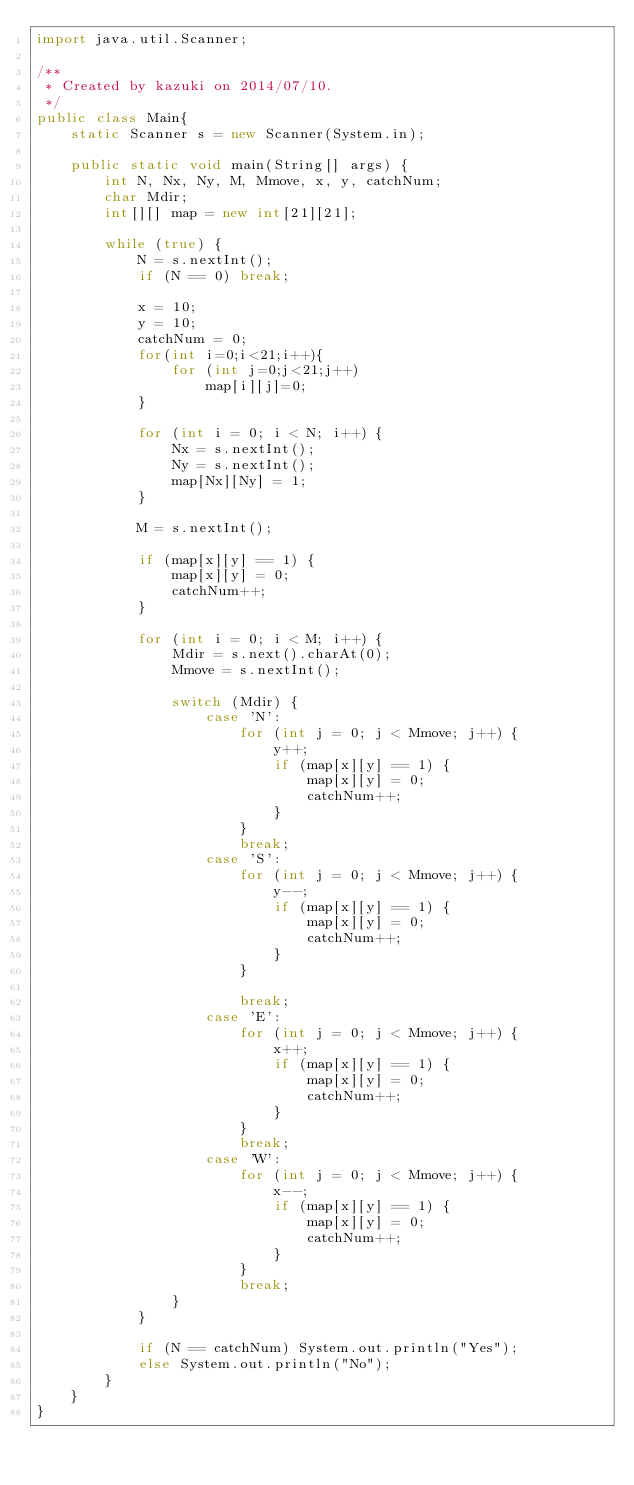<code> <loc_0><loc_0><loc_500><loc_500><_Java_>import java.util.Scanner;

/**
 * Created by kazuki on 2014/07/10.
 */
public class Main{
    static Scanner s = new Scanner(System.in);

    public static void main(String[] args) {
        int N, Nx, Ny, M, Mmove, x, y, catchNum;
        char Mdir;
        int[][] map = new int[21][21];

        while (true) {
            N = s.nextInt();
            if (N == 0) break;

            x = 10;
            y = 10;
            catchNum = 0;
            for(int i=0;i<21;i++){
                for (int j=0;j<21;j++)
                    map[i][j]=0;
            }

            for (int i = 0; i < N; i++) {
                Nx = s.nextInt();
                Ny = s.nextInt();
                map[Nx][Ny] = 1;
            }

            M = s.nextInt();

            if (map[x][y] == 1) {
                map[x][y] = 0;
                catchNum++;
            }

            for (int i = 0; i < M; i++) {
                Mdir = s.next().charAt(0);
                Mmove = s.nextInt();

                switch (Mdir) {
                    case 'N':
                        for (int j = 0; j < Mmove; j++) {
                            y++;
                            if (map[x][y] == 1) {
                                map[x][y] = 0;
                                catchNum++;
                            }
                        }
                        break;
                    case 'S':
                        for (int j = 0; j < Mmove; j++) {
                            y--;
                            if (map[x][y] == 1) {
                                map[x][y] = 0;
                                catchNum++;
                            }
                        }

                        break;
                    case 'E':
                        for (int j = 0; j < Mmove; j++) {
                            x++;
                            if (map[x][y] == 1) {
                                map[x][y] = 0;
                                catchNum++;
                            }
                        }
                        break;
                    case 'W':
                        for (int j = 0; j < Mmove; j++) {
                            x--;
                            if (map[x][y] == 1) {
                                map[x][y] = 0;
                                catchNum++;
                            }
                        }
                        break;
                }
            }

            if (N == catchNum) System.out.println("Yes");
            else System.out.println("No");
        }
    }
}</code> 